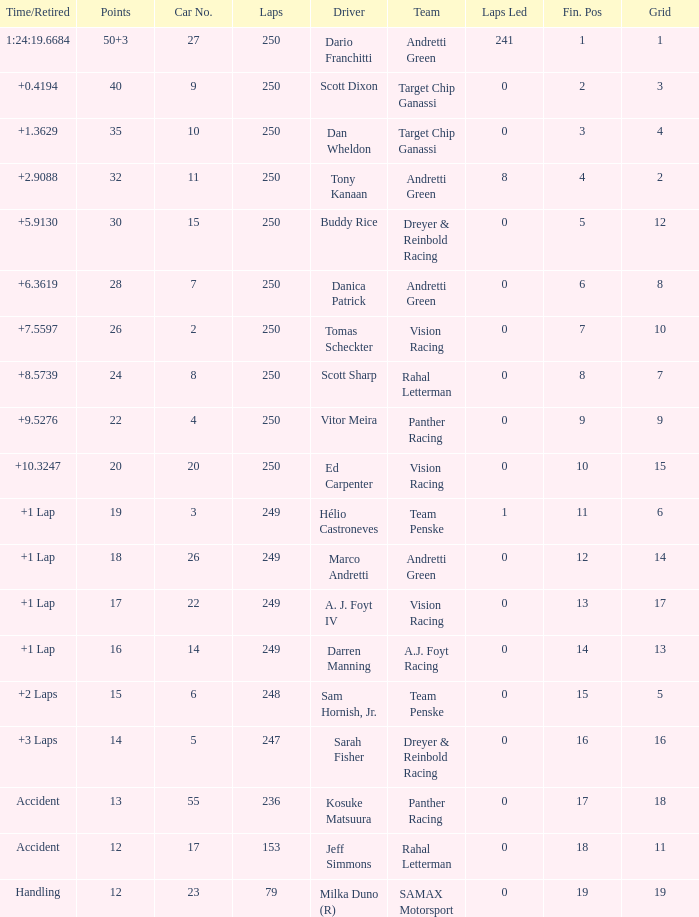Name the total number of fin pos for 12 points of accident 1.0. 